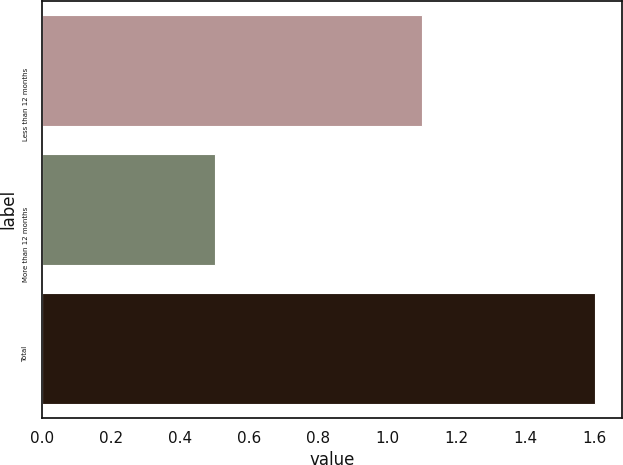Convert chart to OTSL. <chart><loc_0><loc_0><loc_500><loc_500><bar_chart><fcel>Less than 12 months<fcel>More than 12 months<fcel>Total<nl><fcel>1.1<fcel>0.5<fcel>1.6<nl></chart> 